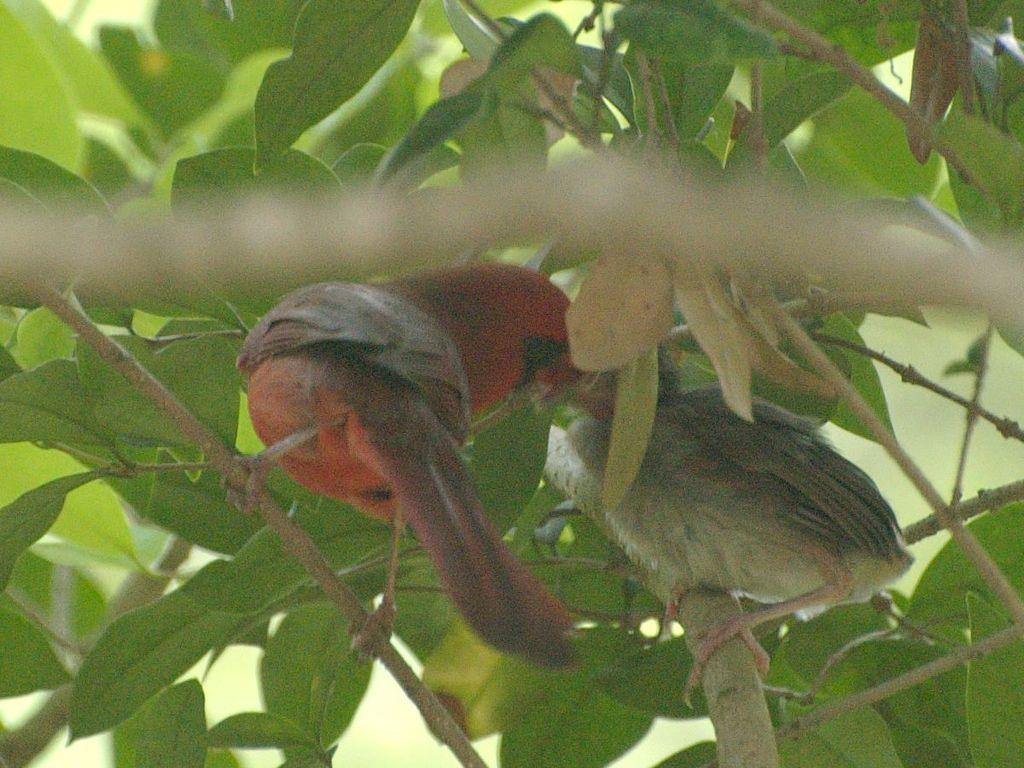How many birds are visible in the image? There are two birds in the image. Where are the birds located? The birds are on the branches of a tree. What is the color of one of the birds? One of the birds is red in color. What type of wall can be seen in the image? There is no wall present in the image; it features two birds on the branches of a tree. 